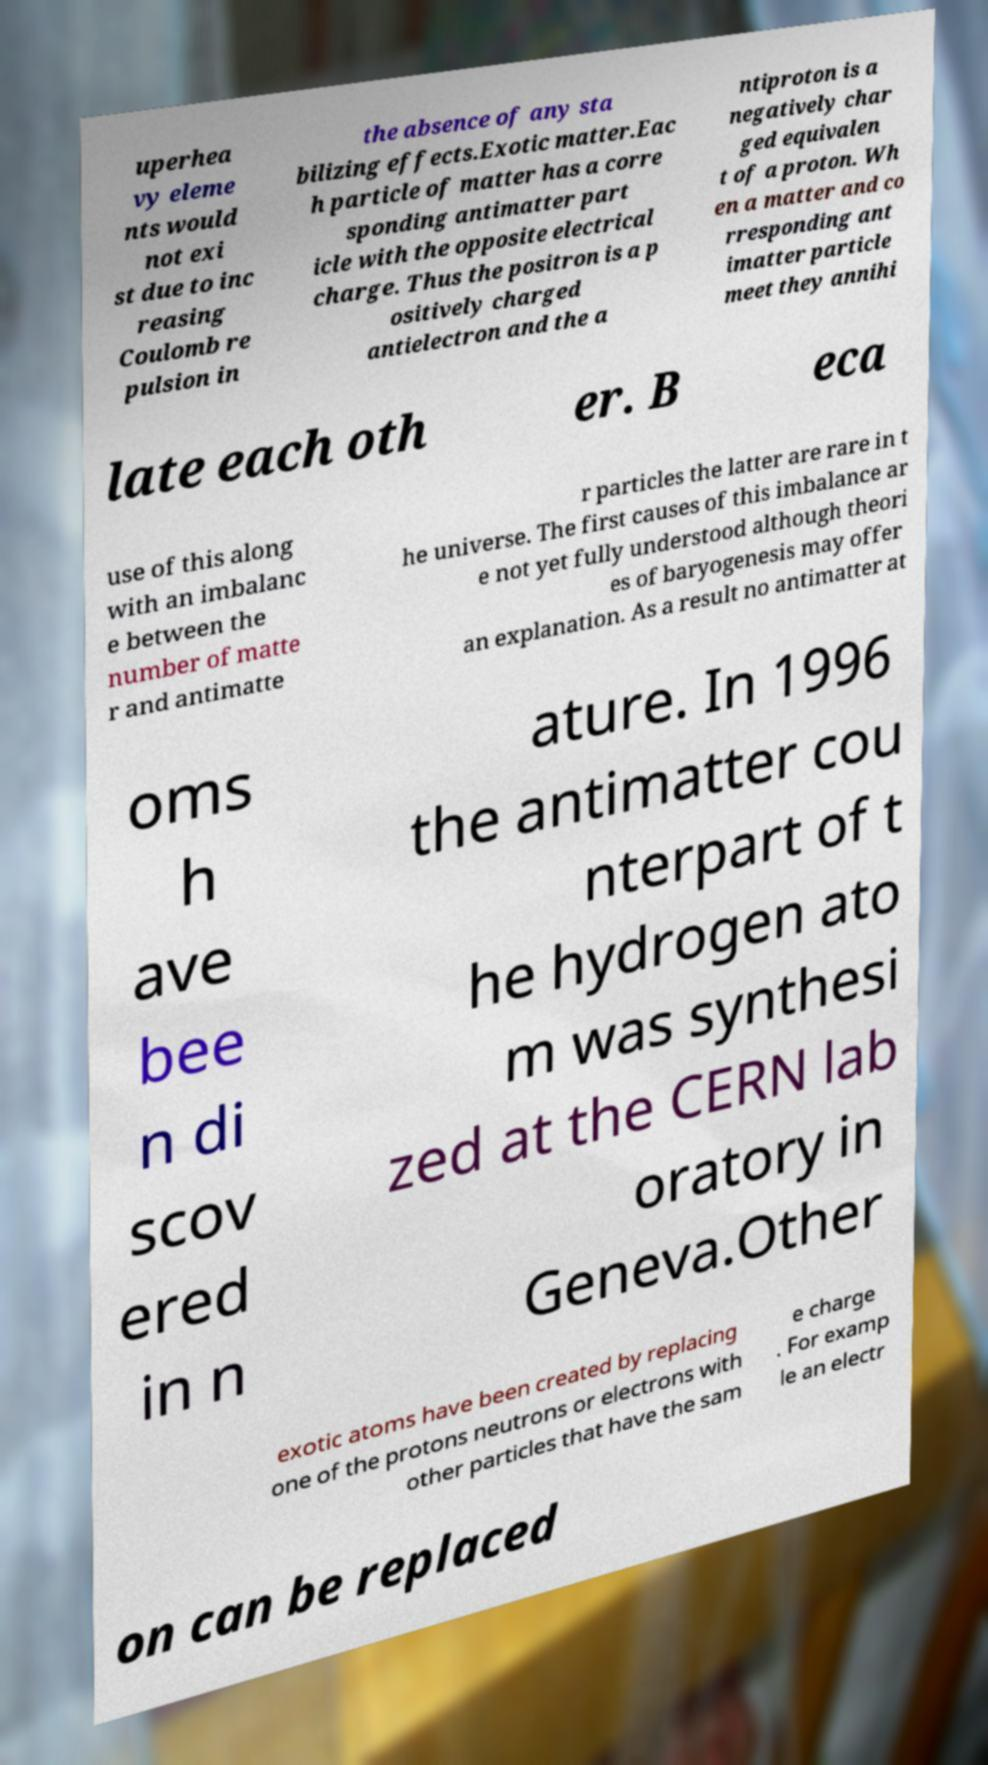I need the written content from this picture converted into text. Can you do that? uperhea vy eleme nts would not exi st due to inc reasing Coulomb re pulsion in the absence of any sta bilizing effects.Exotic matter.Eac h particle of matter has a corre sponding antimatter part icle with the opposite electrical charge. Thus the positron is a p ositively charged antielectron and the a ntiproton is a negatively char ged equivalen t of a proton. Wh en a matter and co rresponding ant imatter particle meet they annihi late each oth er. B eca use of this along with an imbalanc e between the number of matte r and antimatte r particles the latter are rare in t he universe. The first causes of this imbalance ar e not yet fully understood although theori es of baryogenesis may offer an explanation. As a result no antimatter at oms h ave bee n di scov ered in n ature. In 1996 the antimatter cou nterpart of t he hydrogen ato m was synthesi zed at the CERN lab oratory in Geneva.Other exotic atoms have been created by replacing one of the protons neutrons or electrons with other particles that have the sam e charge . For examp le an electr on can be replaced 